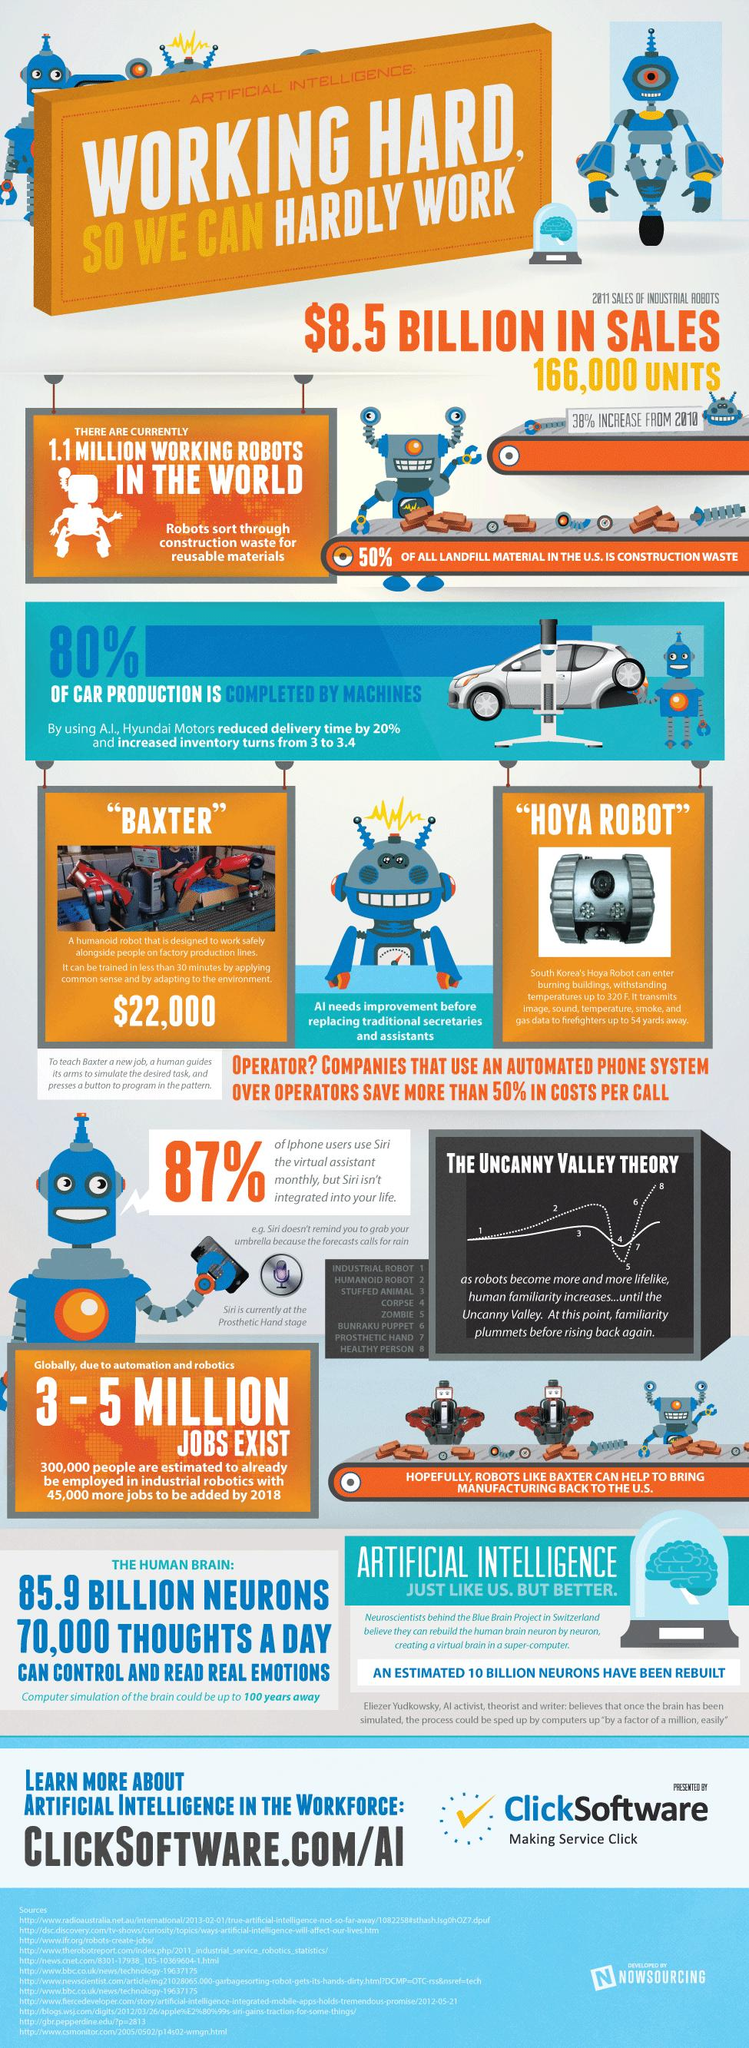Specify some key components in this picture. Approximately 20% of car production is not completed by machines. According to a recent survey, approximately 13% of iPhone users did not use Siri, the virtual assistant, on a monthly basis. 